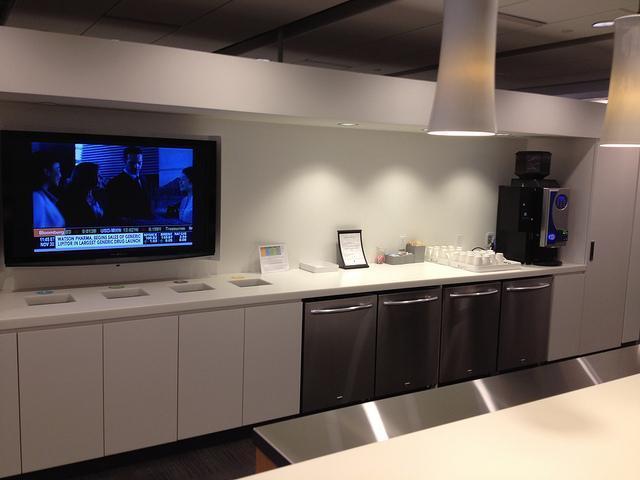How many people are in the picture?
Give a very brief answer. 2. How many refrigerators are there?
Give a very brief answer. 3. 